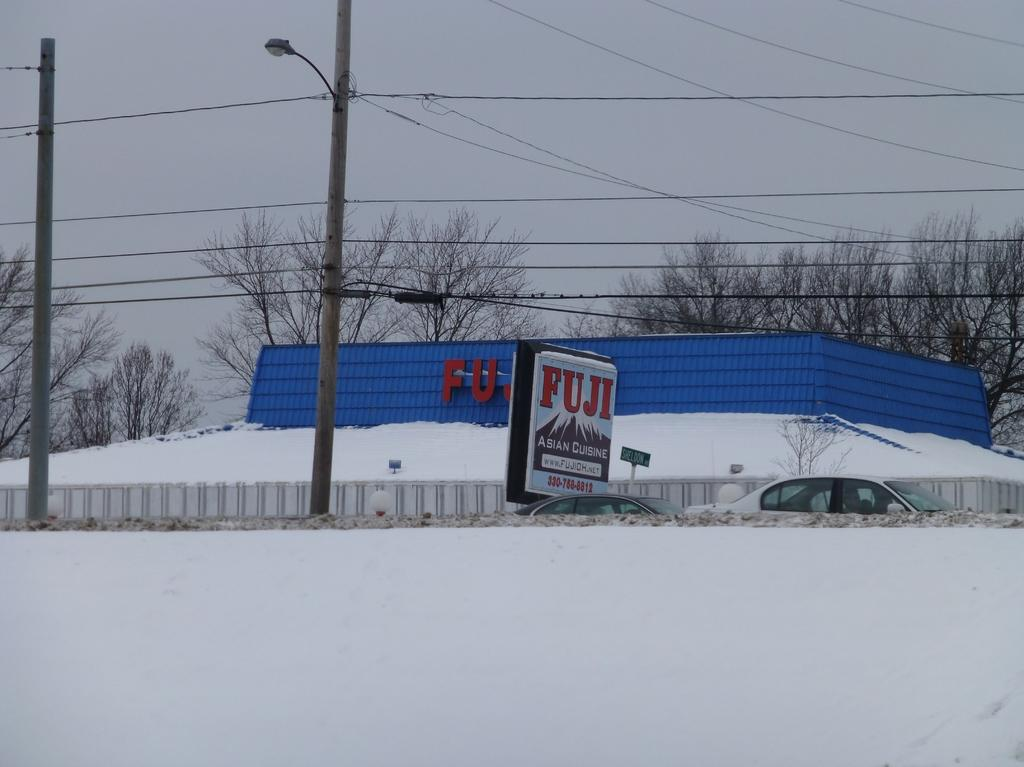<image>
Share a concise interpretation of the image provided. A blue and white building with the word Fuji on it covered in snow. 